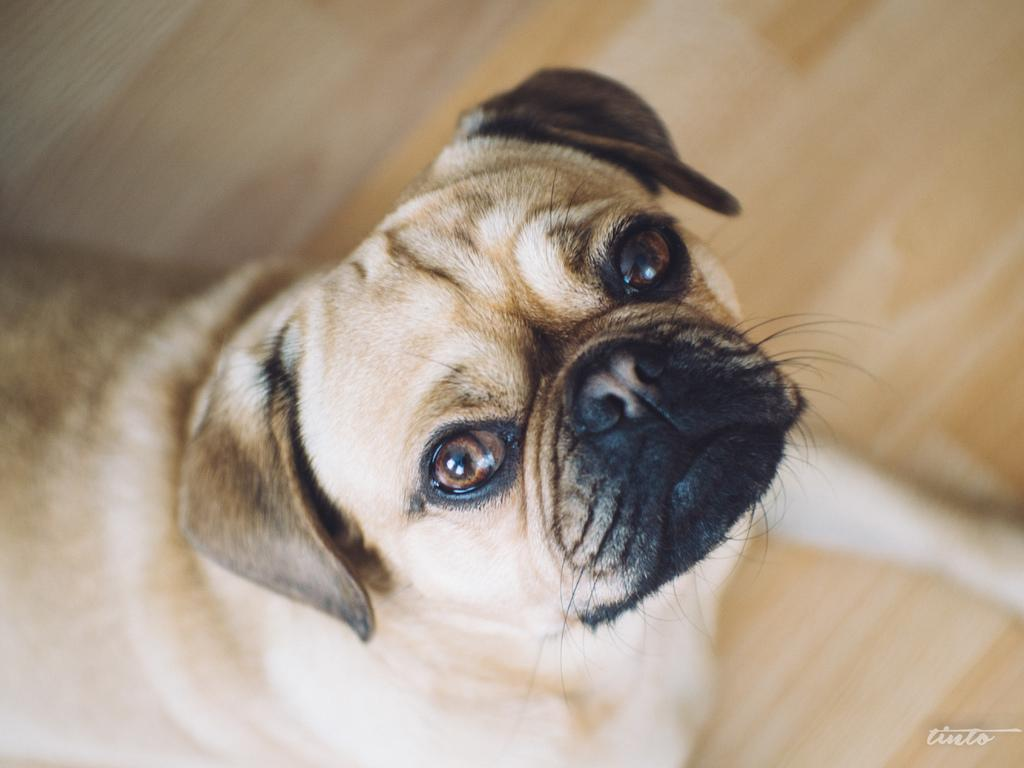What animal is present in the image? There is a dog in the image. Where is the dog located? The dog is on the floor. What is the dog looking at? The dog is looking at a picture. How many snakes are present in the image? There are no snakes present in the image; it features a dog on the floor looking at a picture. What emotion is the dog feeling in the image? The image does not provide information about the dog's emotions, so it cannot be determined from the image. 